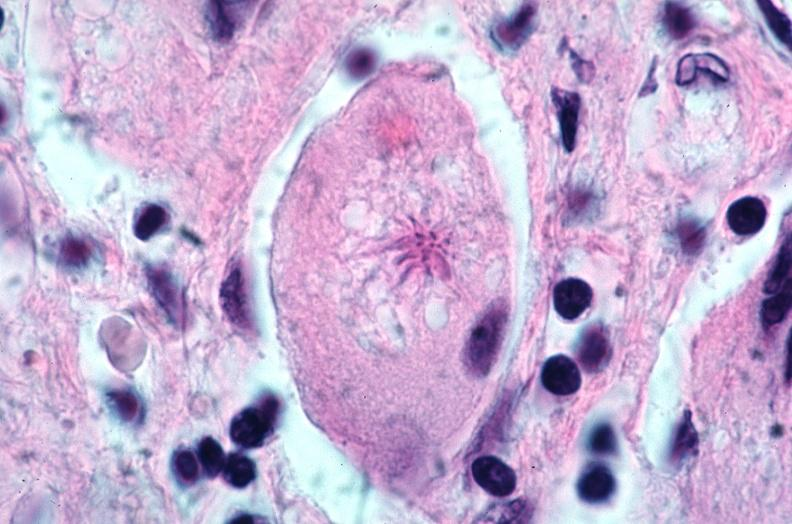how does this image show lung, sarcoidosis, multinucleated giant cells?
Answer the question using a single word or phrase. With asteroid bodies 